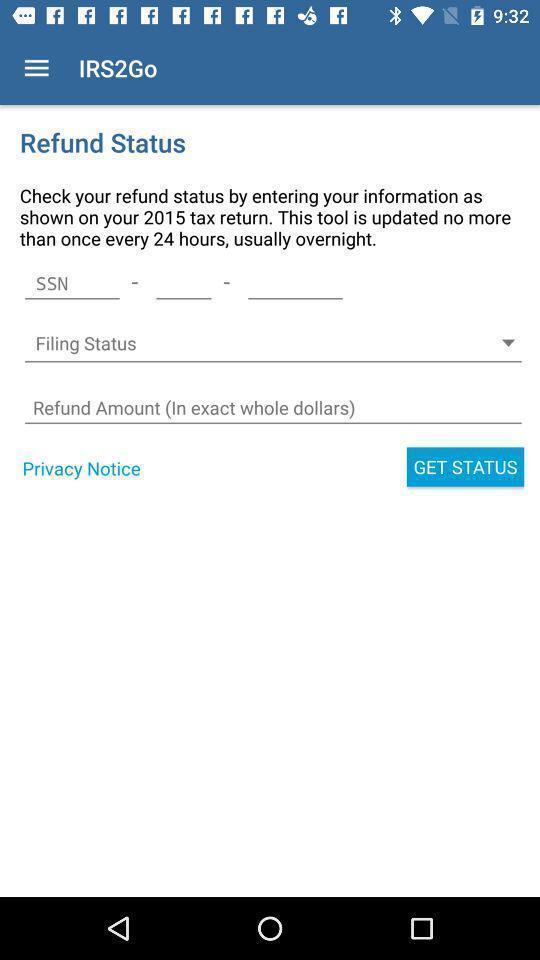Describe the visual elements of this screenshot. Screen shows multiple options in a payment application. 